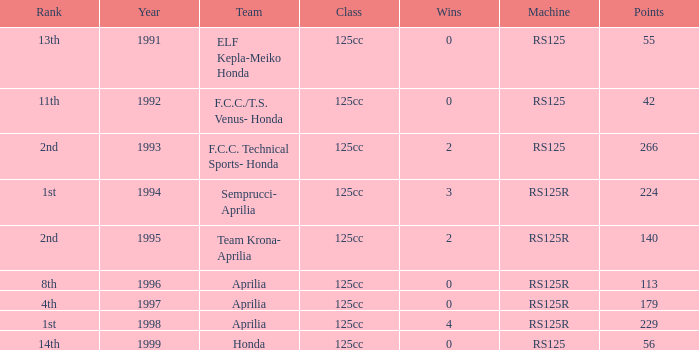Which class had a machine of RS125R, points over 113, and a rank of 4th? 125cc. 